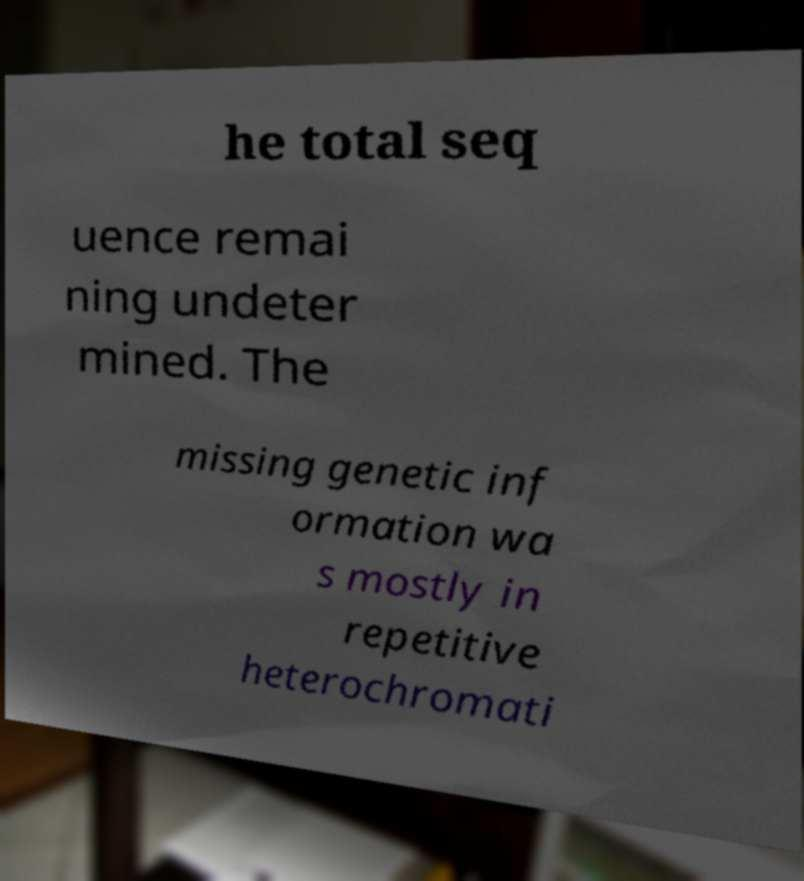Can you accurately transcribe the text from the provided image for me? he total seq uence remai ning undeter mined. The missing genetic inf ormation wa s mostly in repetitive heterochromati 